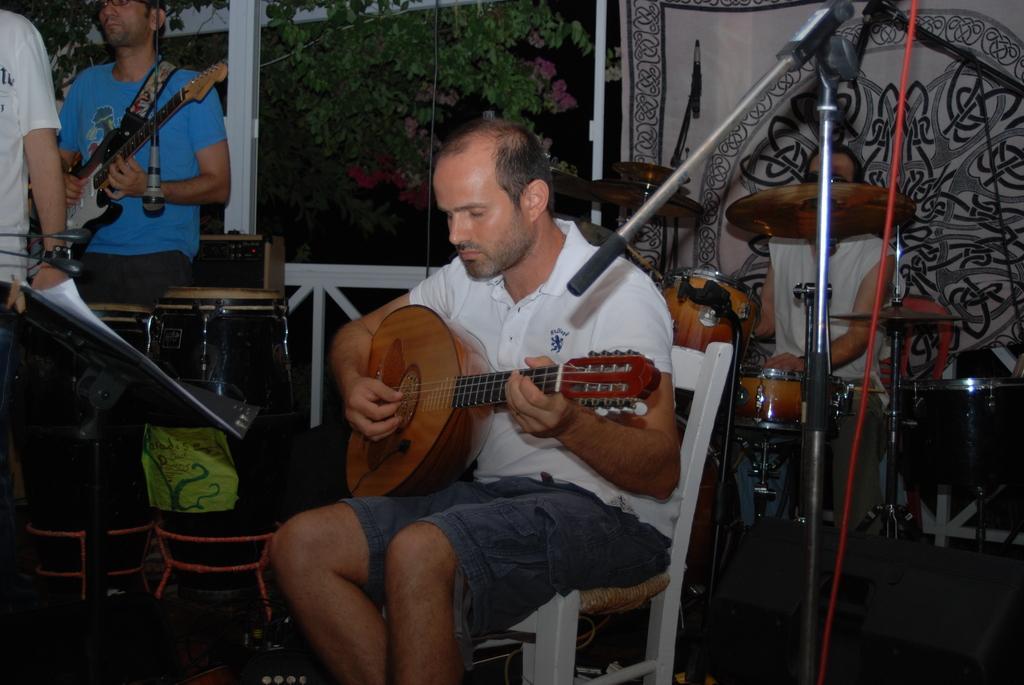Could you give a brief overview of what you see in this image? The image looks like it is clicked in a balcony. There are four persons in this image. In the front, there is a man sitting in a chair, and playing guitar. In the background there is a man sitting and playing drums. To the left, the man wearing blue t-shirt is playing guitar. In the background there is tree, window and railing. 